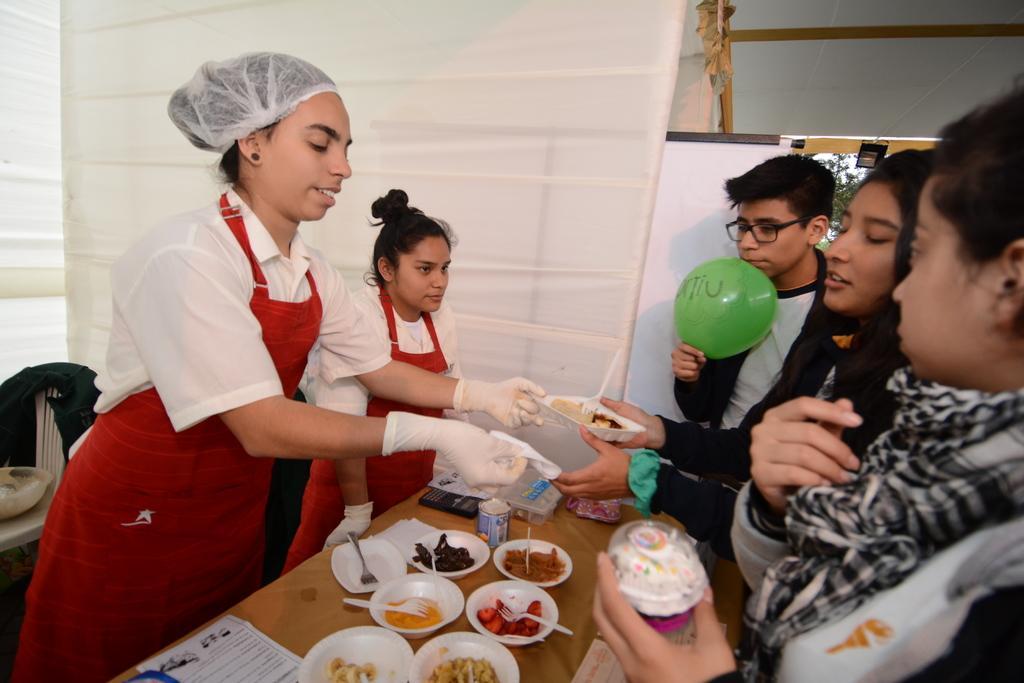Please provide a concise description of this image. In this picture there is a woman who is wearing cap, white shirt, apron and gloves. Beside her there is another woman who is wearing the same dress. Both of the them are standing near to the table. On the table we can see the mobile phone, laptop, cups, forks, stone, ice cream, can and paper. On the right there are three persons were standing at the door. This man who is wearing jacket, t-shirt and spectacle. He is holding a green balloon. On the left there is a jacket on the chair, beside that we can see the bowl on the table. Through the door we can see the trees, sky and light. 